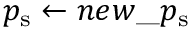<formula> <loc_0><loc_0><loc_500><loc_500>p _ { s } \gets n e w \text  underscore p _{ } { s }</formula> 